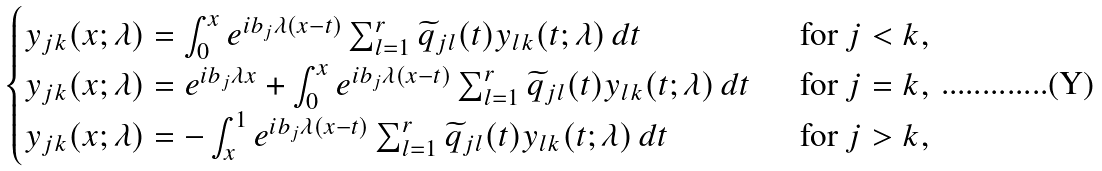<formula> <loc_0><loc_0><loc_500><loc_500>\begin{cases} y _ { j k } ( x ; \lambda ) = \int _ { 0 } ^ { x } e ^ { i b _ { j } \lambda ( x - t ) } \sum _ { l = 1 } ^ { r } \widetilde { q } _ { j l } ( t ) y _ { l k } ( t ; \lambda ) \, d t & \text { \ for } j < k , \\ y _ { j k } ( x ; \lambda ) = e ^ { i b _ { j } \lambda x } + \int _ { 0 } ^ { x } e ^ { i b _ { j } \lambda ( x - t ) } \sum _ { l = 1 } ^ { r } \widetilde { q } _ { j l } ( t ) y _ { l k } ( t ; \lambda ) \, d t & \text { \ for } j = k , \\ y _ { j k } ( x ; \lambda ) = - \int _ { x } ^ { 1 } e ^ { i b _ { j } \lambda ( x - t ) } \sum _ { l = 1 } ^ { r } \widetilde { q } _ { j l } ( t ) y _ { l k } ( t ; \lambda ) \, d t & \text { \ for } j > k , \end{cases}</formula> 